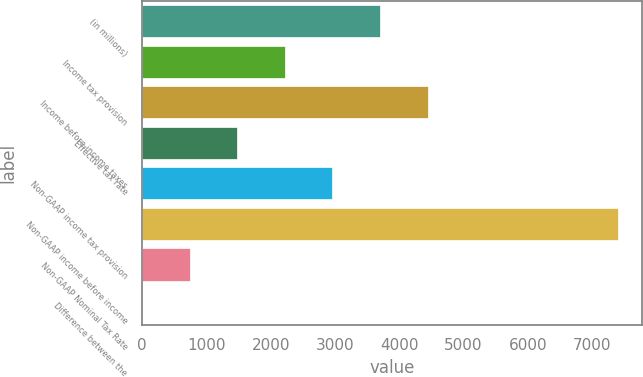Convert chart to OTSL. <chart><loc_0><loc_0><loc_500><loc_500><bar_chart><fcel>(in millions)<fcel>Income tax provision<fcel>Income before income taxes<fcel>Effective tax rate<fcel>Non-GAAP income tax provision<fcel>Non-GAAP income before income<fcel>Non-GAAP Nominal Tax Rate<fcel>Difference between the<nl><fcel>3700.8<fcel>2221.52<fcel>4440.44<fcel>1481.88<fcel>2961.16<fcel>7399<fcel>742.24<fcel>2.6<nl></chart> 